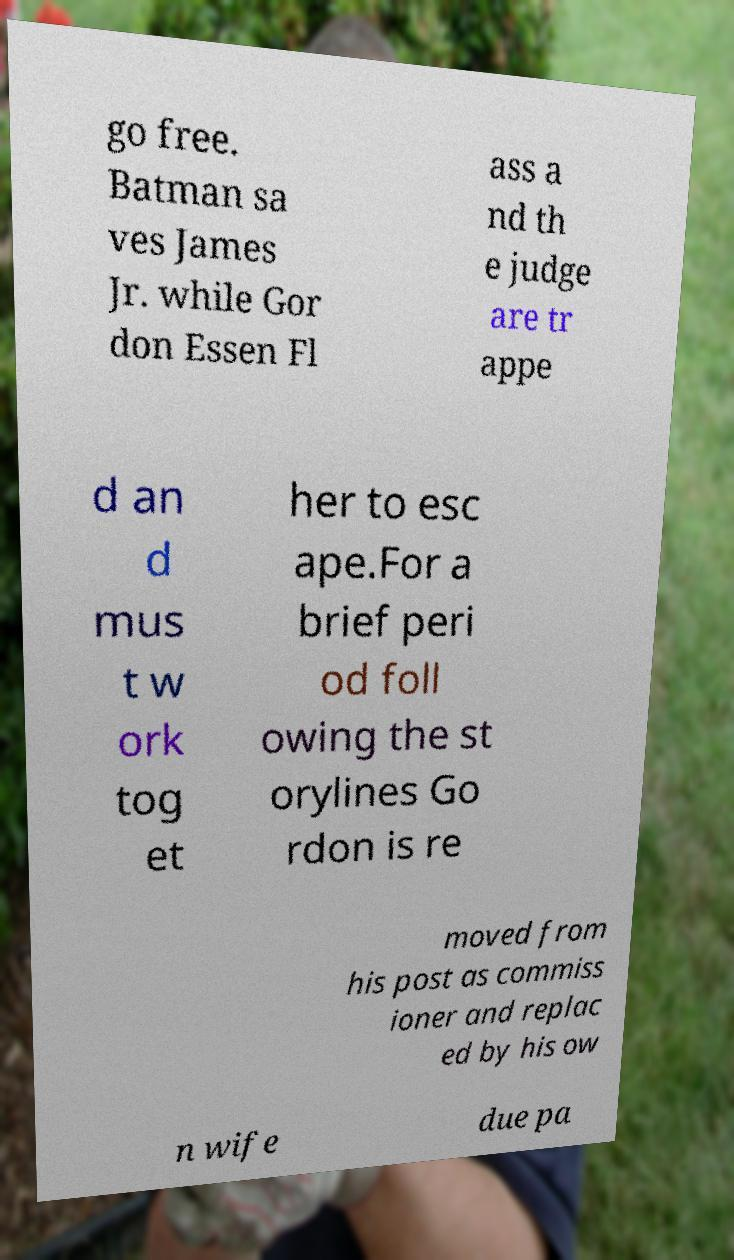Could you assist in decoding the text presented in this image and type it out clearly? go free. Batman sa ves James Jr. while Gor don Essen Fl ass a nd th e judge are tr appe d an d mus t w ork tog et her to esc ape.For a brief peri od foll owing the st orylines Go rdon is re moved from his post as commiss ioner and replac ed by his ow n wife due pa 